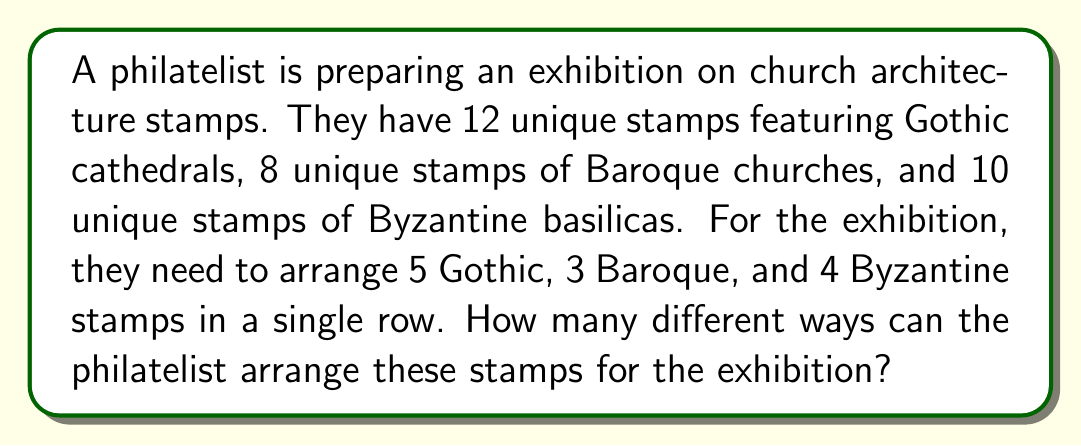Can you solve this math problem? To solve this problem, we'll use the multiplication principle of counting and combinations. Let's break it down step by step:

1) First, we need to choose which stamps to use from each category:
   - Choose 5 out of 12 Gothic cathedral stamps: $\binom{12}{5}$
   - Choose 3 out of 8 Baroque church stamps: $\binom{8}{3}$
   - Choose 4 out of 10 Byzantine basilica stamps: $\binom{10}{4}$

2) The number of ways to choose the stamps is the product of these combinations:

   $$\binom{12}{5} \times \binom{8}{3} \times \binom{10}{4}$$

3) Now, once the stamps are chosen, we need to arrange them. This is a permutation of 12 items (5 + 3 + 4 = 12), which is typically 12!. However, the stamps within each category are interchangeable, so we need to divide by the number of ways to arrange each category:

   $$\frac{12!}{5! \times 3! \times 4!}$$

4) The total number of arrangements is the product of the number of ways to choose the stamps and the number of ways to arrange them:

   $$\binom{12}{5} \times \binom{8}{3} \times \binom{10}{4} \times \frac{12!}{5! \times 3! \times 4!}$$

5) Let's calculate each part:
   $\binom{12}{5} = 792$
   $\binom{8}{3} = 56$
   $\binom{10}{4} = 210$
   $\frac{12!}{5! \times 3! \times 4!} = 27,720$

6) Multiplying these together:

   $$792 \times 56 \times 210 \times 27,720 = 257,833,728,000$$

Therefore, there are 257,833,728,000 different ways to arrange the stamps for the exhibition.
Answer: 257,833,728,000 